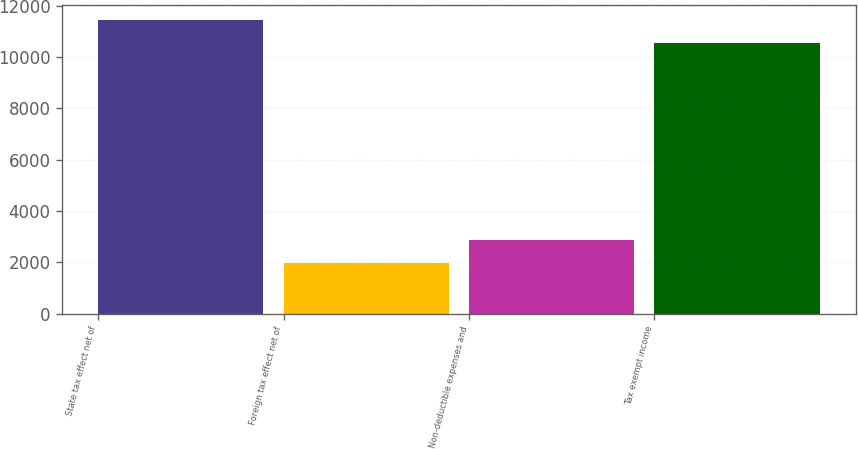Convert chart to OTSL. <chart><loc_0><loc_0><loc_500><loc_500><bar_chart><fcel>State tax effect net of<fcel>Foreign tax effect net of<fcel>Non-deductible expenses and<fcel>Tax exempt income<nl><fcel>11459.1<fcel>1969<fcel>2886.1<fcel>10542<nl></chart> 